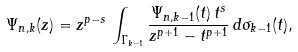Convert formula to latex. <formula><loc_0><loc_0><loc_500><loc_500>\Psi _ { n , k } ( z ) = z ^ { p - s } \, \int _ { \Gamma _ { k - 1 } } \frac { \Psi _ { n , k - 1 } ( t ) \, t ^ { s } } { z ^ { p + 1 } - t ^ { p + 1 } } \, d \sigma _ { k - 1 } ( t ) ,</formula> 